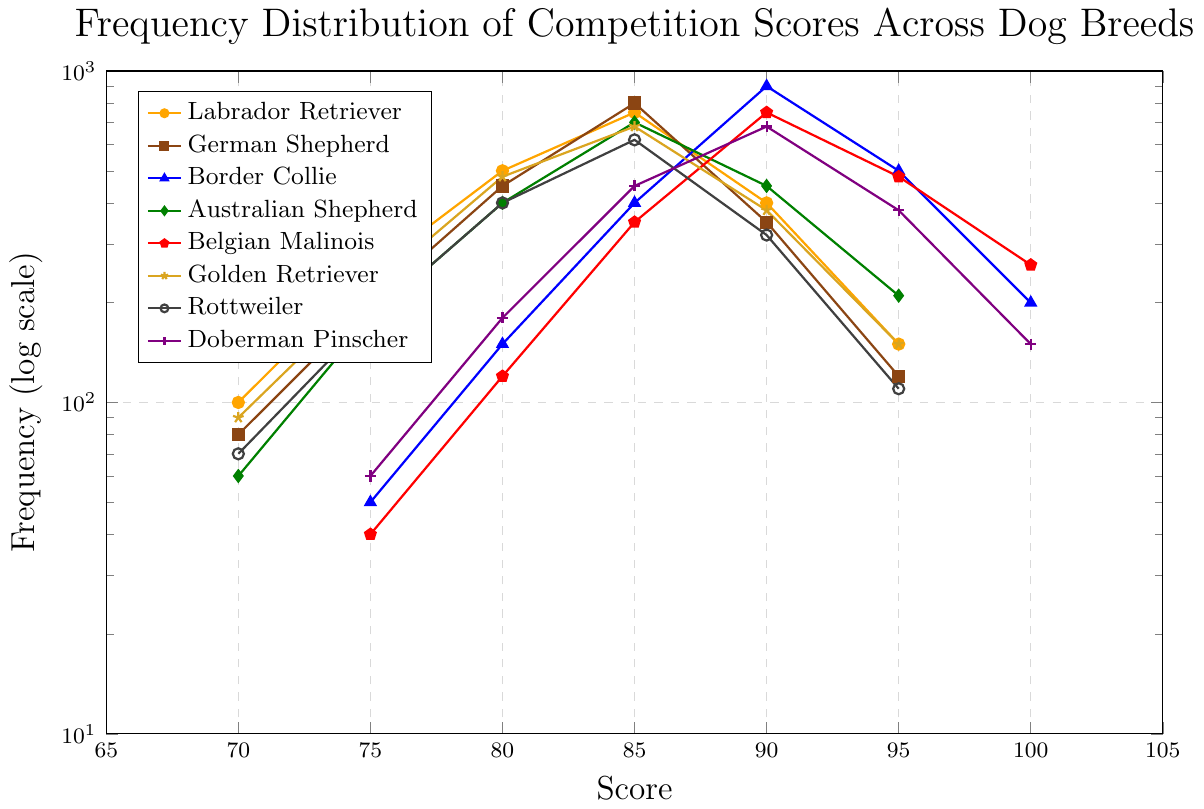Which breed has the highest frequency for the score of 85? According to the chart, find the score of 85 on the x-axis and see which breed's line reaches the highest value on the y-axis for that score. The German Shepherd reaches 800 which is the highest.
Answer: German Shepherd Which breed has the lowest frequency at a score of 95? Locate the score of 95 on the x-axis and compare the corresponding frequency values of the breeds. The Rottweiler has the lowest value with 110.
Answer: Rottweiler How does the frequency distribution of the Belgian Malinois compare with the Border Collie at a score of 100? At a score of 100 on the x-axis, compare the frequency values of Belgian Malinois and Border Collie. The Belgian Malinois has a frequency of 260, while the Border Collie has a frequency of 200.
Answer: Belgian Malinois has a higher frequency than the Border Collie Which breed shows the most consistent frequency increase with higher scores? Look at each breed's trend line; 'consistent frequency increase' means the breed whose trend line mostly moves upward as the score increases. The Australian Shepherd shows consistent increases in frequency from scores 70 through 95.
Answer: Australian Shepherd How does the maximum frequency value of the Golden Retriever compare with that of the Rottweiler? Identify the peak frequencies for both Golden Retriever and Rottweiler on the y-axis. The maximum for the Golden Retriever is 680 at a score of 85, and for the Rottweiler, it is 620 at a score of 85.
Answer: Golden Retriever's maximum frequency is higher What is the total frequency for Doberman Pinscher at scores 85 through 100? Sum the frequencies of the Doberman Pinscher at scores 85 (450), 90 (680), 95 (380), and 100 (150). So, 450 + 680 + 380 + 150 = 1660.
Answer: 1660 At which score does the Border Collie have its peak frequency, and what is that frequency? Check the chart for the highest point in the Border Collie's line. The highest point is at a score of 90 with a frequency of 900.
Answer: 90 and 900 Which breed shows a decline in frequency immediately after achieving their peak value? Look at the trend lines after the highest point for each breed. The Labrador Retriever, for example, peaks at 85 (750) and then decreases to 400 at 90 and further down to 150 at 95.
Answer: Labrador Retriever What is the average frequency for the German Shepherd at scores 70, 75, and 80? Sum the frequencies of the German Shepherd at these scores: 80 + 200 + 450 = 730, then divide by 3 scores, hence 730/3 ≈ 243.33.
Answer: 243.33 What color is used to represent the Australian Shepherd, and how can you tell? Observe the legend in the chart. The Australian Shepherd is indicated by a green color with a diamond marker.
Answer: Green 